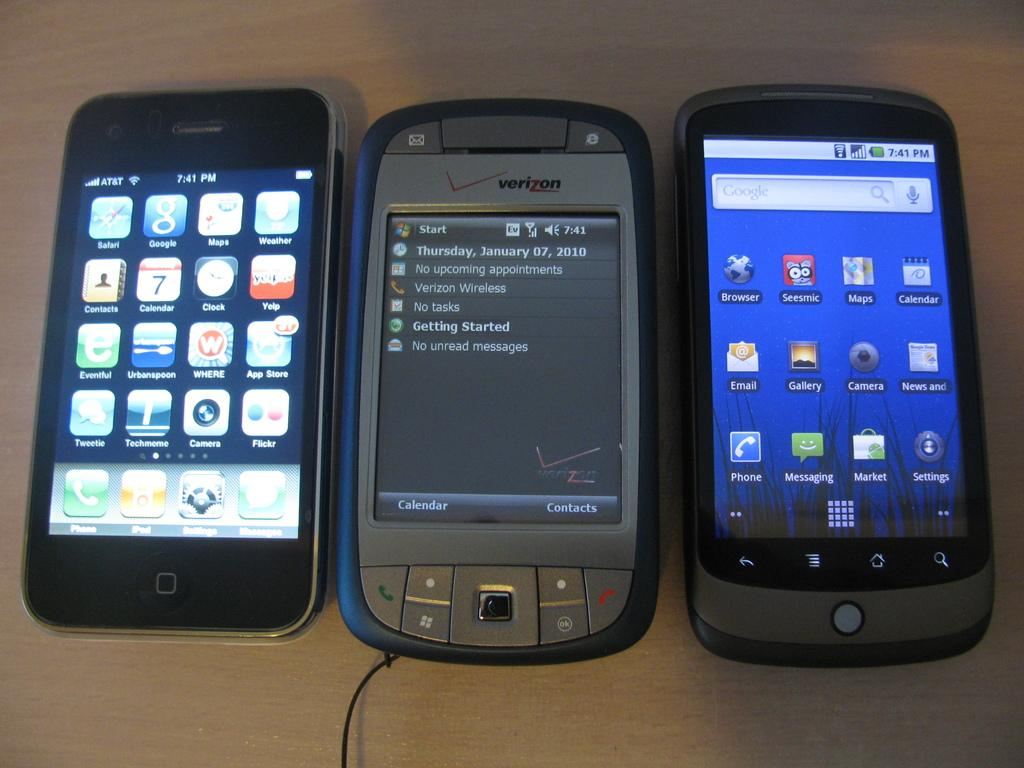Provide a one-sentence caption for the provided image. Three old cell phones on a table including a Verizon phone and an Apple iPhone. 